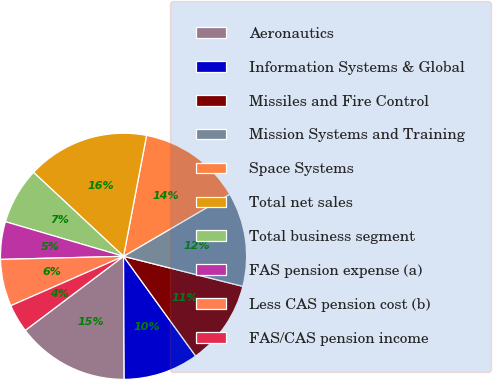<chart> <loc_0><loc_0><loc_500><loc_500><pie_chart><fcel>Aeronautics<fcel>Information Systems & Global<fcel>Missiles and Fire Control<fcel>Mission Systems and Training<fcel>Space Systems<fcel>Total net sales<fcel>Total business segment<fcel>FAS pension expense (a)<fcel>Less CAS pension cost (b)<fcel>FAS/CAS pension income<nl><fcel>14.81%<fcel>9.88%<fcel>11.11%<fcel>12.35%<fcel>13.58%<fcel>16.05%<fcel>7.41%<fcel>4.94%<fcel>6.17%<fcel>3.7%<nl></chart> 